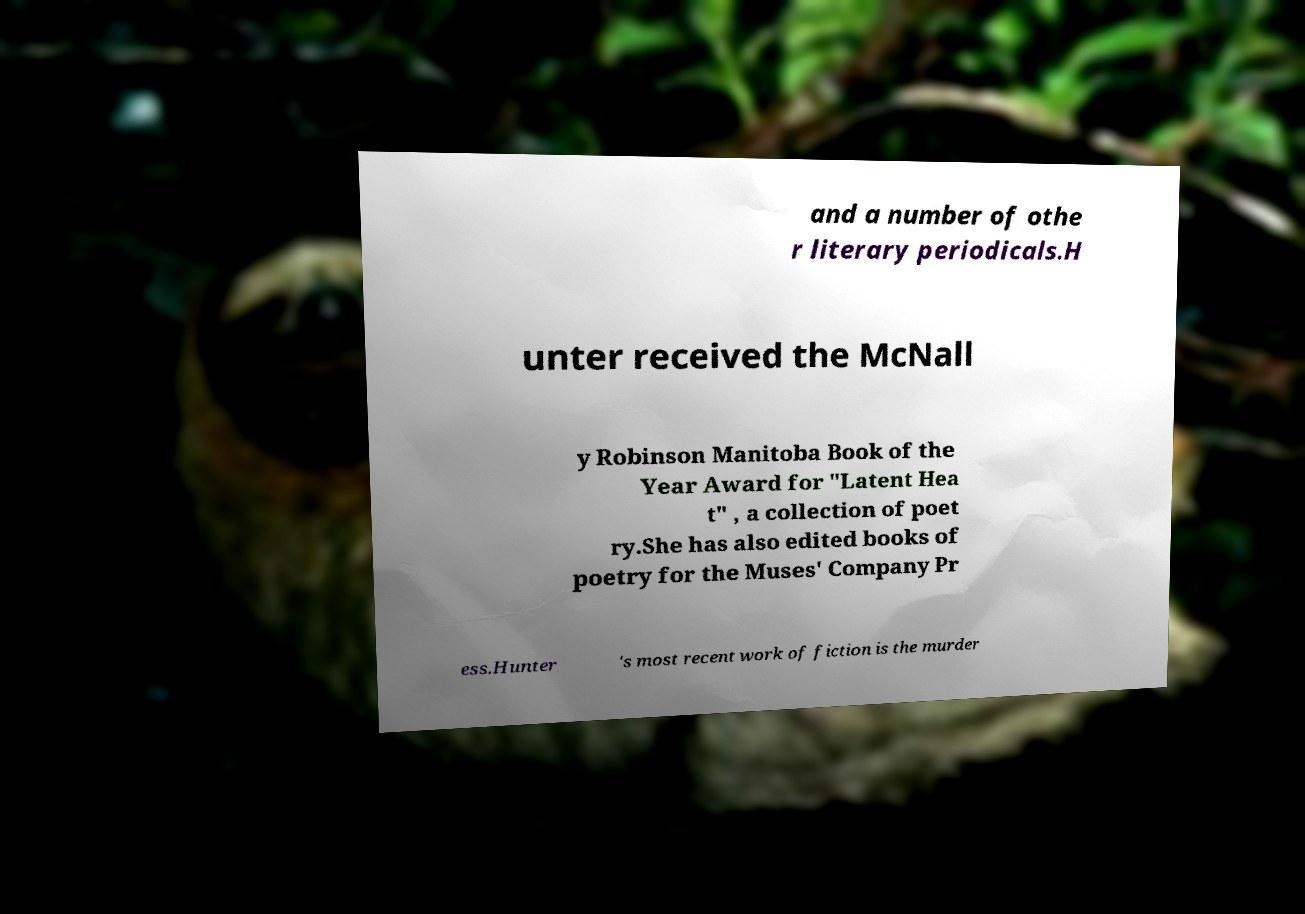Could you assist in decoding the text presented in this image and type it out clearly? and a number of othe r literary periodicals.H unter received the McNall y Robinson Manitoba Book of the Year Award for "Latent Hea t" , a collection of poet ry.She has also edited books of poetry for the Muses' Company Pr ess.Hunter 's most recent work of fiction is the murder 